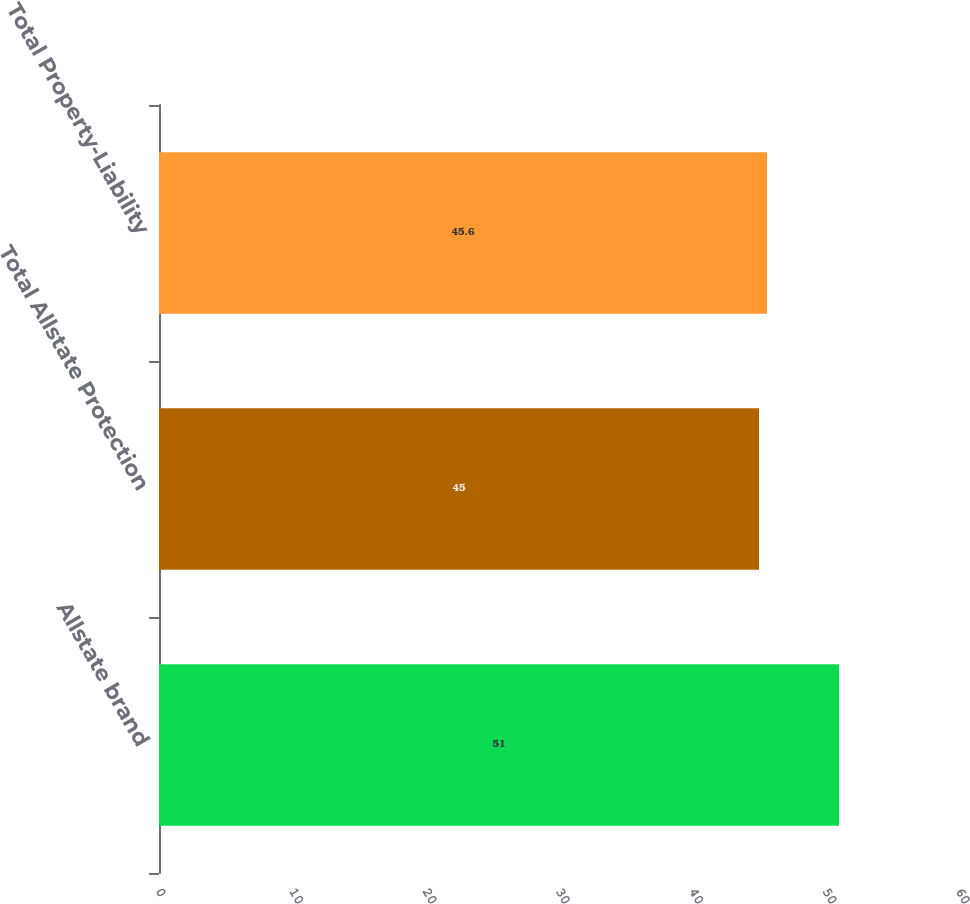<chart> <loc_0><loc_0><loc_500><loc_500><bar_chart><fcel>Allstate brand<fcel>Total Allstate Protection<fcel>Total Property-Liability<nl><fcel>51<fcel>45<fcel>45.6<nl></chart> 